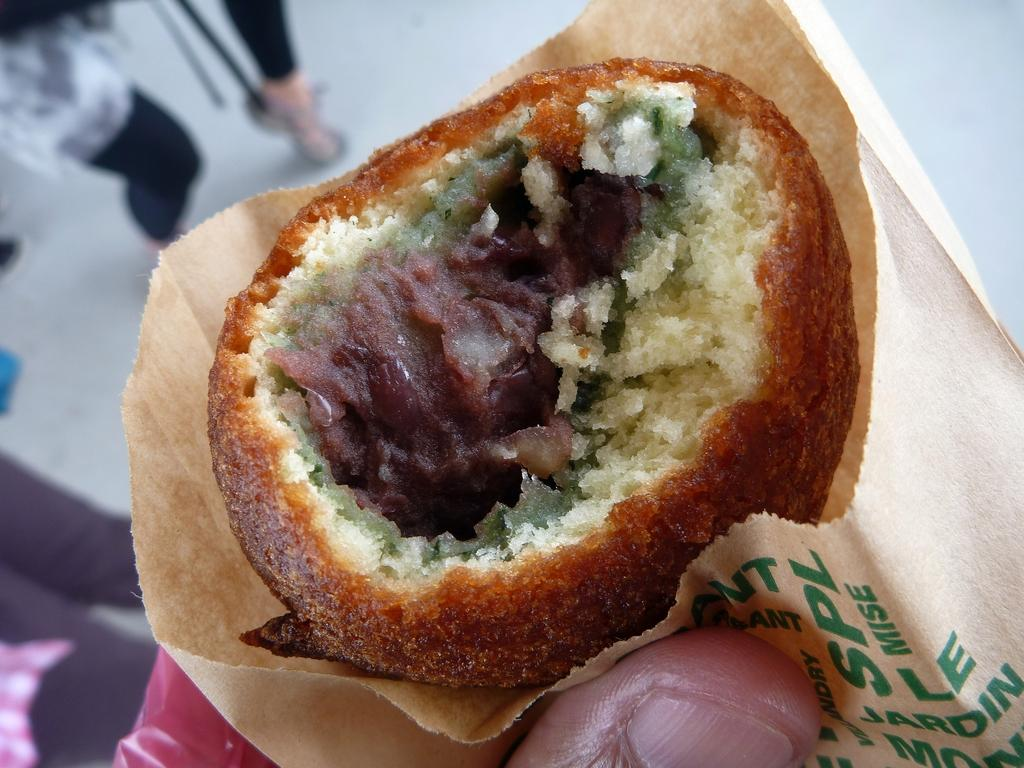What is the person holding in the image? The person's thumb is holding a cover in the image. What can be found inside the cover? There is a food item inside the cover. What is happening in the background of the image? There are persons on the floor in the background of the image. How would you describe the quality of the image? The image appears to be blurry. What type of horse can be seen playing the drum in the image? There is no horse or drum present in the image. What color is the cub in the image? There is no cub present in the image. 